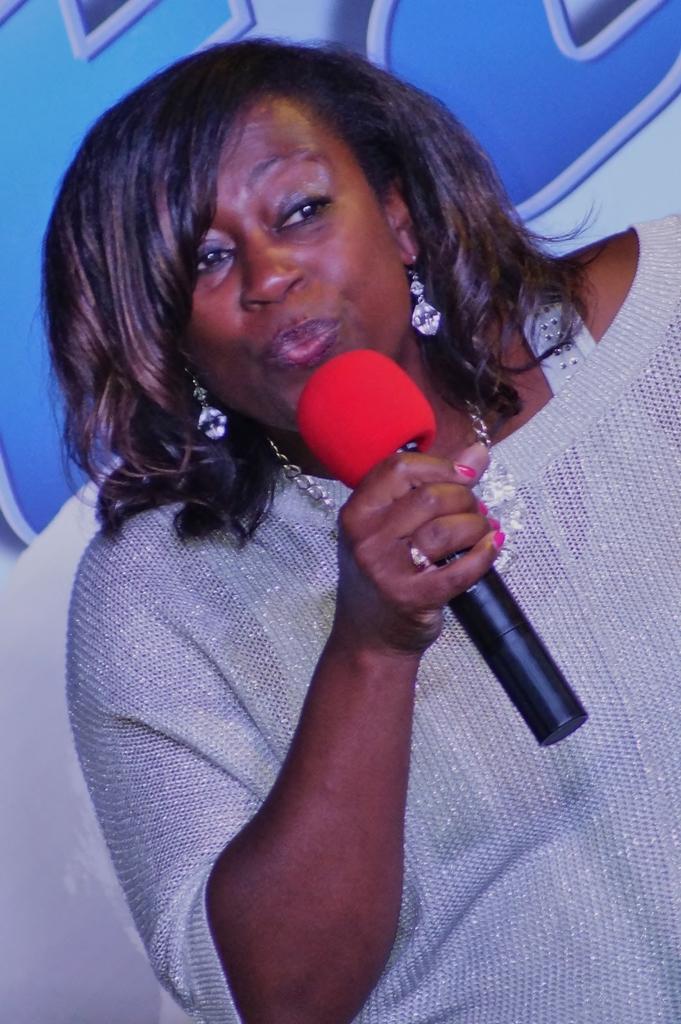How would you summarize this image in a sentence or two? In this image there is a woman talking in a microphone and at the background there is a hoarding. 